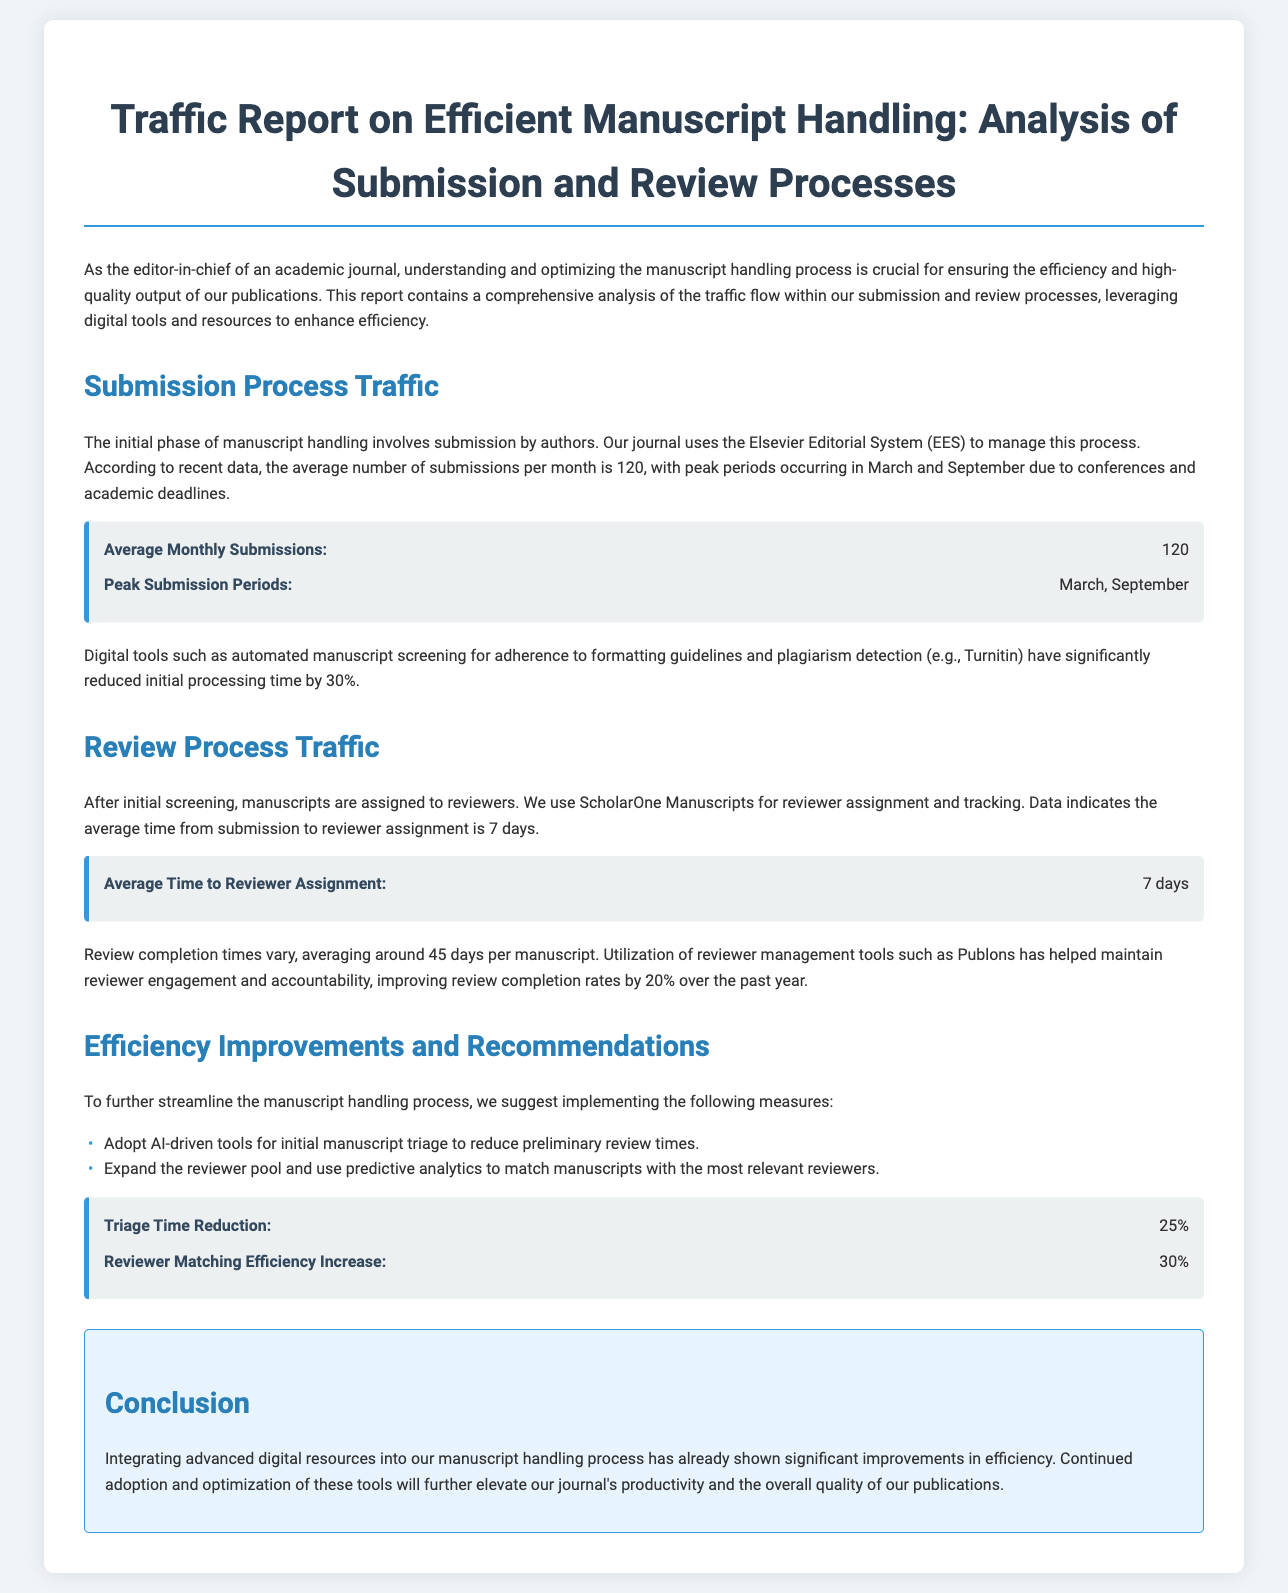What is the average number of submissions per month? The document states that the average number of submissions per month is 120.
Answer: 120 Which two months are identified as peak submission periods? According to the document, peak submission periods occur in March and September.
Answer: March, September What is the average time from submission to reviewer assignment? The text mentions that the average time from submission to reviewer assignment is 7 days.
Answer: 7 days What is the average review completion time? The document indicates that the average review completion time is around 45 days per manuscript.
Answer: 45 days By what percentage has review completion rates improved over the past year? The document notes that reviewer management tools have improved review completion rates by 20% over the past year.
Answer: 20% What technology is suggested for initial manuscript triage? The report suggests the adoption of AI-driven tools for initial manuscript triage.
Answer: AI-driven tools What is the proposed reduction in triage time? The document states that the proposed triage time reduction is 25%.
Answer: 25% How much has reviewer matching efficiency been proposed to increase? The report suggests that reviewer matching efficiency could increase by 30%.
Answer: 30% What system is used to manage the submission process? The document mentions that the Elsevier Editorial System (EES) is used to manage the submission process.
Answer: Elsevier Editorial System (EES) 